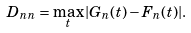Convert formula to latex. <formula><loc_0><loc_0><loc_500><loc_500>D _ { n n } = \max _ { t } | G _ { n } ( t ) - F _ { n } ( t ) | .</formula> 